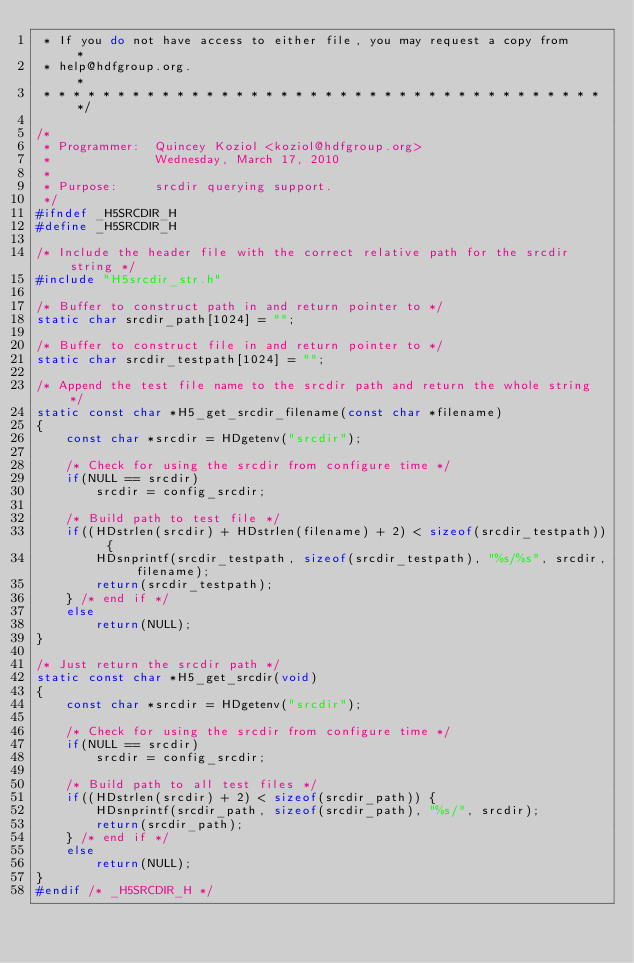<code> <loc_0><loc_0><loc_500><loc_500><_C_> * If you do not have access to either file, you may request a copy from     *
 * help@hdfgroup.org.                                                        *
 * * * * * * * * * * * * * * * * * * * * * * * * * * * * * * * * * * * * * * */

/*
 * Programmer:  Quincey Koziol <koziol@hdfgroup.org>
 *              Wednesday, March 17, 2010
 *
 * Purpose:     srcdir querying support.
 */
#ifndef _H5SRCDIR_H
#define _H5SRCDIR_H

/* Include the header file with the correct relative path for the srcdir string */
#include "H5srcdir_str.h"

/* Buffer to construct path in and return pointer to */
static char srcdir_path[1024] = "";

/* Buffer to construct file in and return pointer to */
static char srcdir_testpath[1024] = "";

/* Append the test file name to the srcdir path and return the whole string */
static const char *H5_get_srcdir_filename(const char *filename)
{
    const char *srcdir = HDgetenv("srcdir");

    /* Check for using the srcdir from configure time */
    if(NULL == srcdir)
        srcdir = config_srcdir;

    /* Build path to test file */
    if((HDstrlen(srcdir) + HDstrlen(filename) + 2) < sizeof(srcdir_testpath)) {
        HDsnprintf(srcdir_testpath, sizeof(srcdir_testpath), "%s/%s", srcdir, filename);
        return(srcdir_testpath);
    } /* end if */
    else
        return(NULL);
}

/* Just return the srcdir path */
static const char *H5_get_srcdir(void)
{
    const char *srcdir = HDgetenv("srcdir");

    /* Check for using the srcdir from configure time */
    if(NULL == srcdir)
        srcdir = config_srcdir;

    /* Build path to all test files */
    if((HDstrlen(srcdir) + 2) < sizeof(srcdir_path)) {
        HDsnprintf(srcdir_path, sizeof(srcdir_path), "%s/", srcdir);
        return(srcdir_path);
    } /* end if */
    else
        return(NULL);
}
#endif /* _H5SRCDIR_H */

</code> 